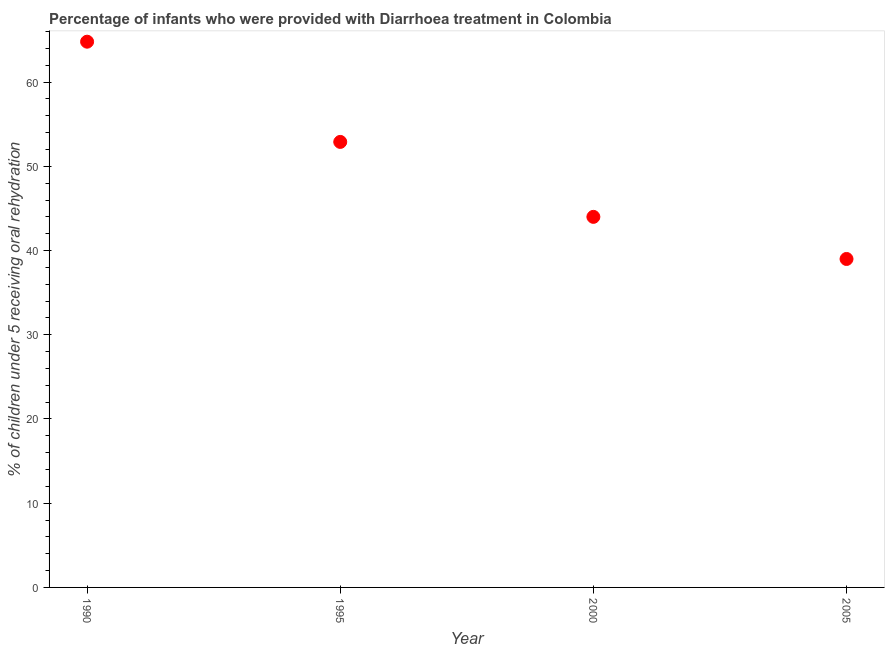What is the percentage of children who were provided with treatment diarrhoea in 1995?
Ensure brevity in your answer.  52.9. Across all years, what is the maximum percentage of children who were provided with treatment diarrhoea?
Make the answer very short. 64.8. Across all years, what is the minimum percentage of children who were provided with treatment diarrhoea?
Provide a succinct answer. 39. In which year was the percentage of children who were provided with treatment diarrhoea maximum?
Make the answer very short. 1990. What is the sum of the percentage of children who were provided with treatment diarrhoea?
Your answer should be very brief. 200.7. What is the difference between the percentage of children who were provided with treatment diarrhoea in 1990 and 2000?
Your response must be concise. 20.8. What is the average percentage of children who were provided with treatment diarrhoea per year?
Keep it short and to the point. 50.17. What is the median percentage of children who were provided with treatment diarrhoea?
Your answer should be very brief. 48.45. What is the ratio of the percentage of children who were provided with treatment diarrhoea in 1995 to that in 2000?
Your answer should be compact. 1.2. Is the percentage of children who were provided with treatment diarrhoea in 1995 less than that in 2005?
Ensure brevity in your answer.  No. What is the difference between the highest and the second highest percentage of children who were provided with treatment diarrhoea?
Your answer should be very brief. 11.9. Is the sum of the percentage of children who were provided with treatment diarrhoea in 1995 and 2005 greater than the maximum percentage of children who were provided with treatment diarrhoea across all years?
Provide a succinct answer. Yes. What is the difference between the highest and the lowest percentage of children who were provided with treatment diarrhoea?
Provide a succinct answer. 25.8. Does the percentage of children who were provided with treatment diarrhoea monotonically increase over the years?
Provide a short and direct response. No. How many dotlines are there?
Give a very brief answer. 1. How many years are there in the graph?
Ensure brevity in your answer.  4. Are the values on the major ticks of Y-axis written in scientific E-notation?
Offer a very short reply. No. What is the title of the graph?
Provide a succinct answer. Percentage of infants who were provided with Diarrhoea treatment in Colombia. What is the label or title of the Y-axis?
Provide a short and direct response. % of children under 5 receiving oral rehydration. What is the % of children under 5 receiving oral rehydration in 1990?
Provide a succinct answer. 64.8. What is the % of children under 5 receiving oral rehydration in 1995?
Offer a terse response. 52.9. What is the difference between the % of children under 5 receiving oral rehydration in 1990 and 1995?
Your response must be concise. 11.9. What is the difference between the % of children under 5 receiving oral rehydration in 1990 and 2000?
Provide a short and direct response. 20.8. What is the difference between the % of children under 5 receiving oral rehydration in 1990 and 2005?
Your answer should be compact. 25.8. What is the difference between the % of children under 5 receiving oral rehydration in 1995 and 2000?
Make the answer very short. 8.9. What is the difference between the % of children under 5 receiving oral rehydration in 1995 and 2005?
Offer a very short reply. 13.9. What is the ratio of the % of children under 5 receiving oral rehydration in 1990 to that in 1995?
Give a very brief answer. 1.23. What is the ratio of the % of children under 5 receiving oral rehydration in 1990 to that in 2000?
Provide a short and direct response. 1.47. What is the ratio of the % of children under 5 receiving oral rehydration in 1990 to that in 2005?
Provide a succinct answer. 1.66. What is the ratio of the % of children under 5 receiving oral rehydration in 1995 to that in 2000?
Offer a terse response. 1.2. What is the ratio of the % of children under 5 receiving oral rehydration in 1995 to that in 2005?
Offer a terse response. 1.36. What is the ratio of the % of children under 5 receiving oral rehydration in 2000 to that in 2005?
Provide a succinct answer. 1.13. 